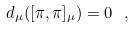<formula> <loc_0><loc_0><loc_500><loc_500>d _ { \mu } ( [ \pi , \pi ] _ { \mu } ) = 0 \ ,</formula> 